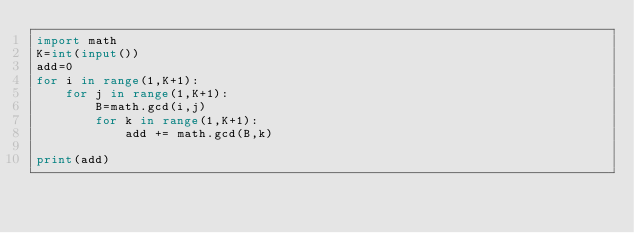Convert code to text. <code><loc_0><loc_0><loc_500><loc_500><_Python_>import math
K=int(input())
add=0
for i in range(1,K+1):
    for j in range(1,K+1):
        B=math.gcd(i,j)
        for k in range(1,K+1):
            add += math.gcd(B,k)
           
print(add)
            
        </code> 